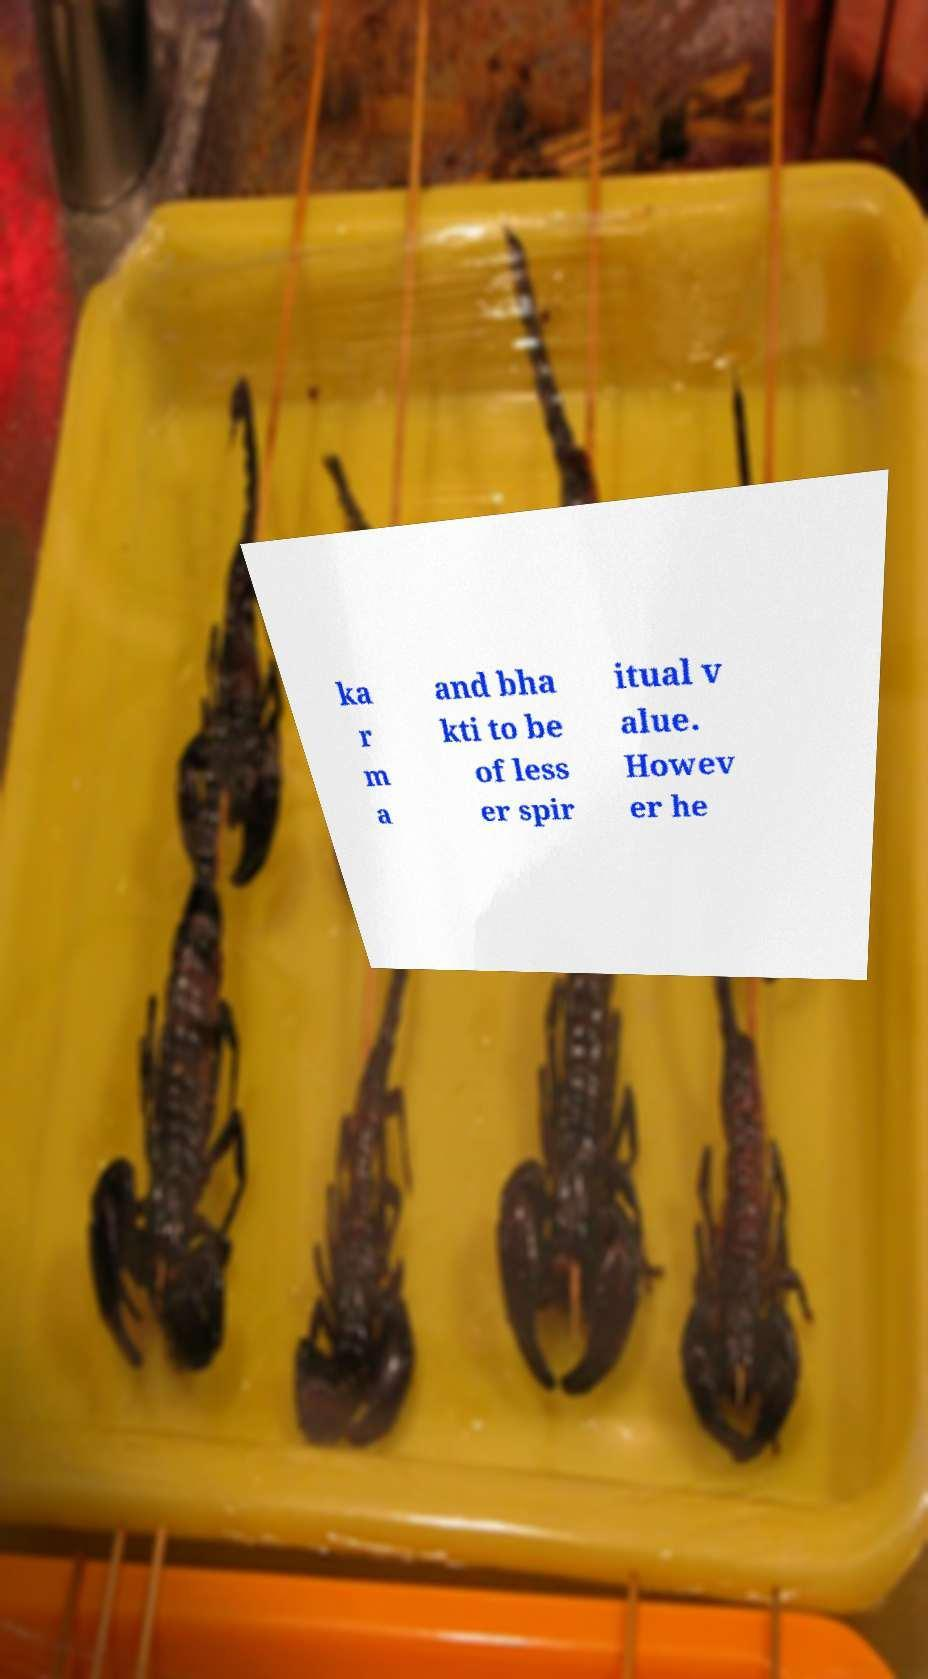What messages or text are displayed in this image? I need them in a readable, typed format. ka r m a and bha kti to be of less er spir itual v alue. Howev er he 